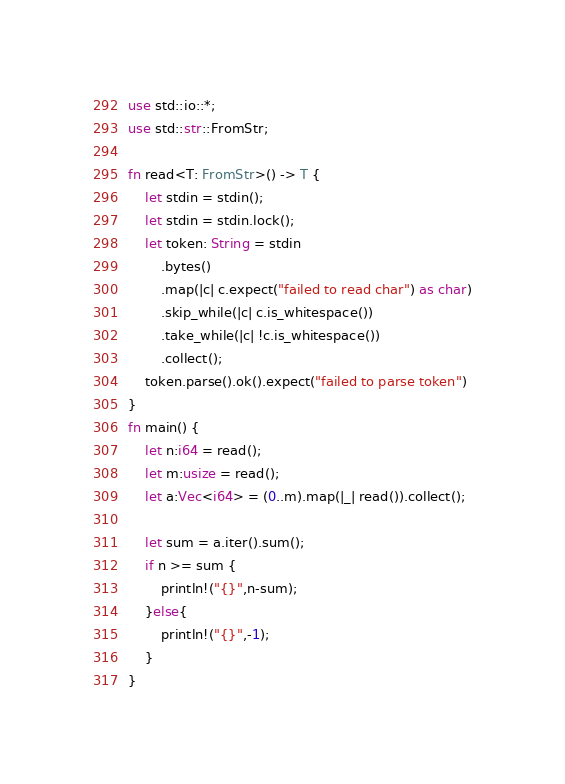<code> <loc_0><loc_0><loc_500><loc_500><_Rust_>use std::io::*;
use std::str::FromStr;

fn read<T: FromStr>() -> T {
    let stdin = stdin();
    let stdin = stdin.lock();
    let token: String = stdin
        .bytes()
        .map(|c| c.expect("failed to read char") as char)
        .skip_while(|c| c.is_whitespace())
        .take_while(|c| !c.is_whitespace())
        .collect();
    token.parse().ok().expect("failed to parse token")
}
fn main() {
    let n:i64 = read();
    let m:usize = read();
    let a:Vec<i64> = (0..m).map(|_| read()).collect();

    let sum = a.iter().sum();
    if n >= sum {
        println!("{}",n-sum);
    }else{
        println!("{}",-1);
    }
}
</code> 